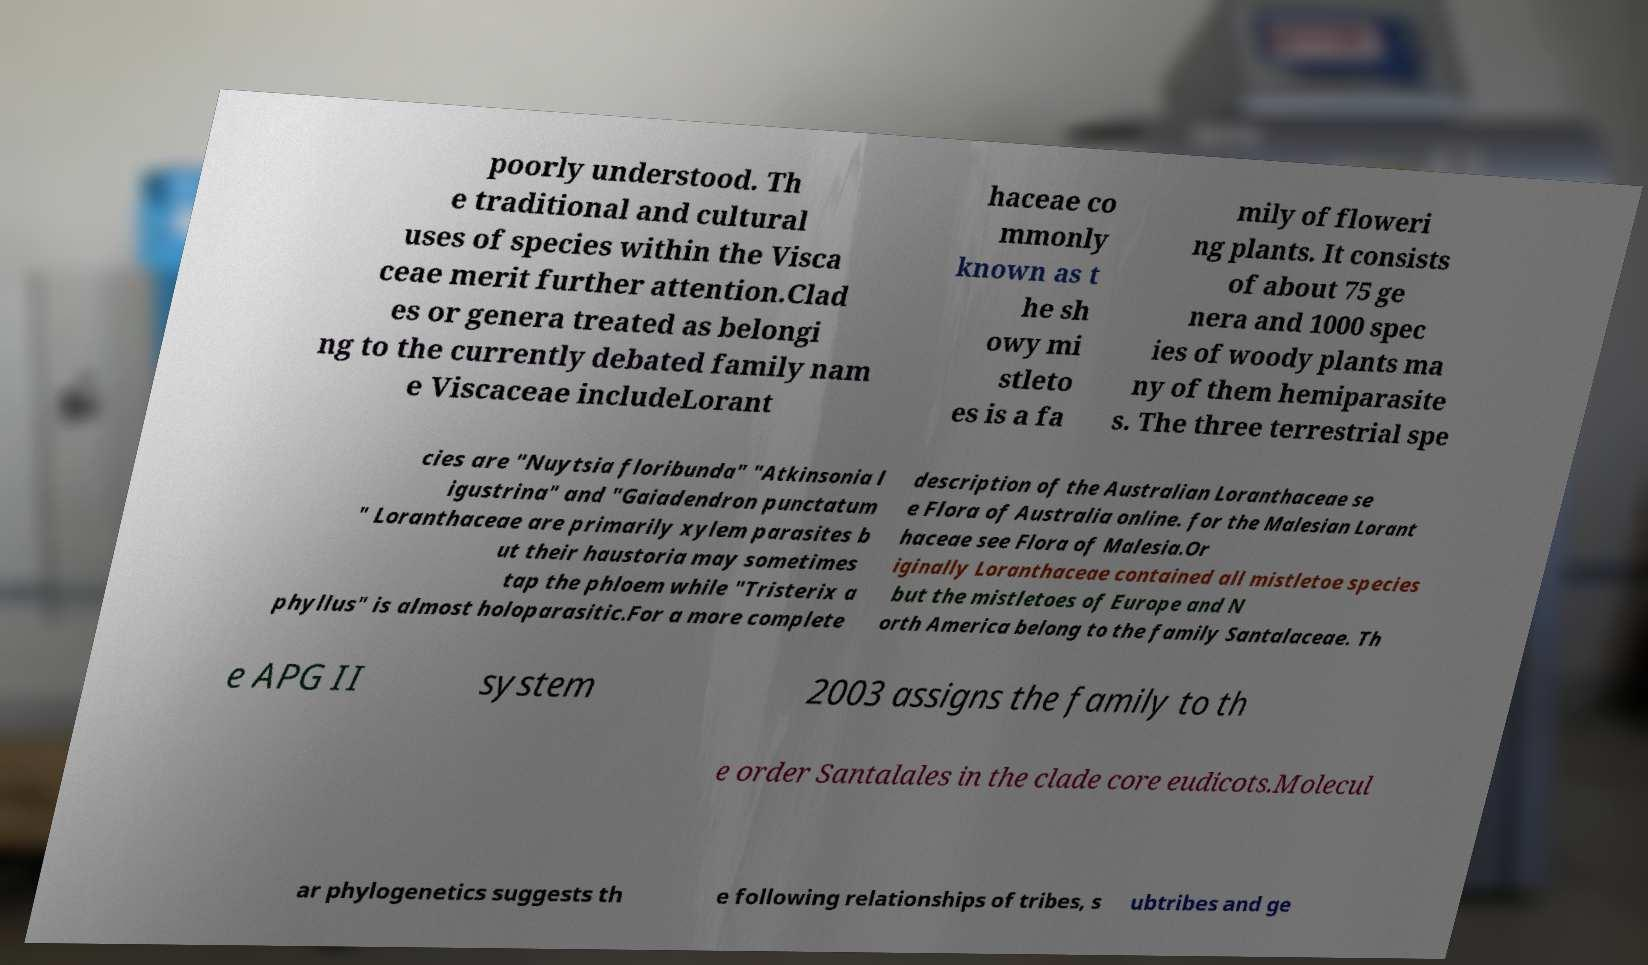Could you extract and type out the text from this image? poorly understood. Th e traditional and cultural uses of species within the Visca ceae merit further attention.Clad es or genera treated as belongi ng to the currently debated family nam e Viscaceae includeLorant haceae co mmonly known as t he sh owy mi stleto es is a fa mily of floweri ng plants. It consists of about 75 ge nera and 1000 spec ies of woody plants ma ny of them hemiparasite s. The three terrestrial spe cies are "Nuytsia floribunda" "Atkinsonia l igustrina" and "Gaiadendron punctatum " Loranthaceae are primarily xylem parasites b ut their haustoria may sometimes tap the phloem while "Tristerix a phyllus" is almost holoparasitic.For a more complete description of the Australian Loranthaceae se e Flora of Australia online. for the Malesian Lorant haceae see Flora of Malesia.Or iginally Loranthaceae contained all mistletoe species but the mistletoes of Europe and N orth America belong to the family Santalaceae. Th e APG II system 2003 assigns the family to th e order Santalales in the clade core eudicots.Molecul ar phylogenetics suggests th e following relationships of tribes, s ubtribes and ge 